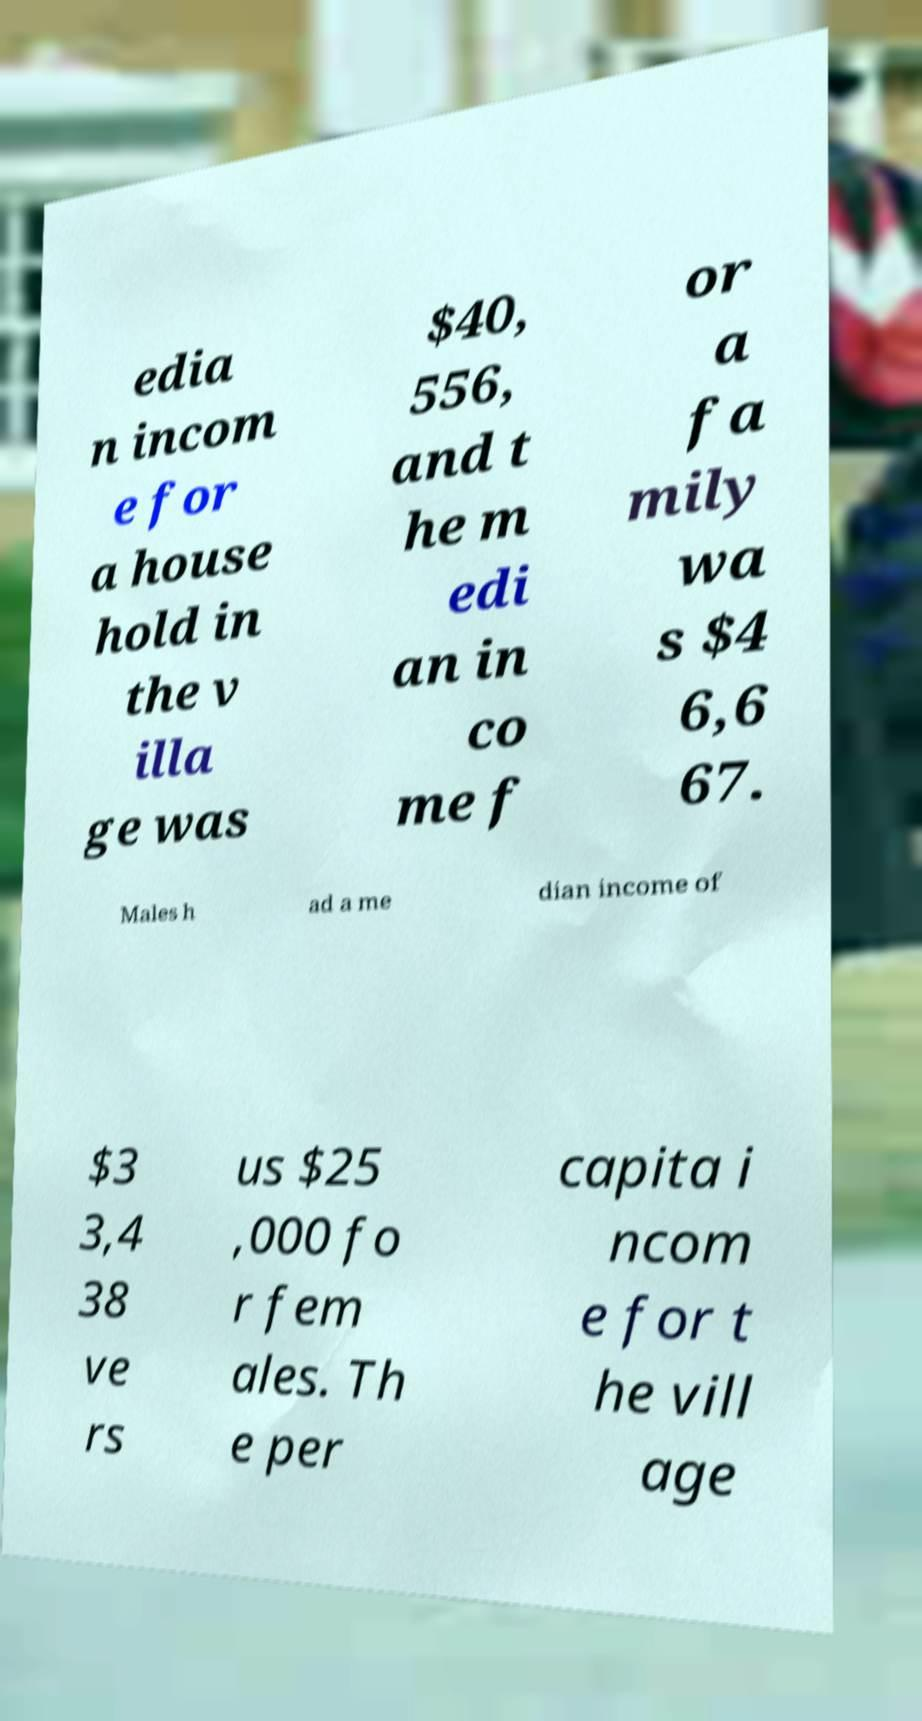What messages or text are displayed in this image? I need them in a readable, typed format. edia n incom e for a house hold in the v illa ge was $40, 556, and t he m edi an in co me f or a fa mily wa s $4 6,6 67. Males h ad a me dian income of $3 3,4 38 ve rs us $25 ,000 fo r fem ales. Th e per capita i ncom e for t he vill age 